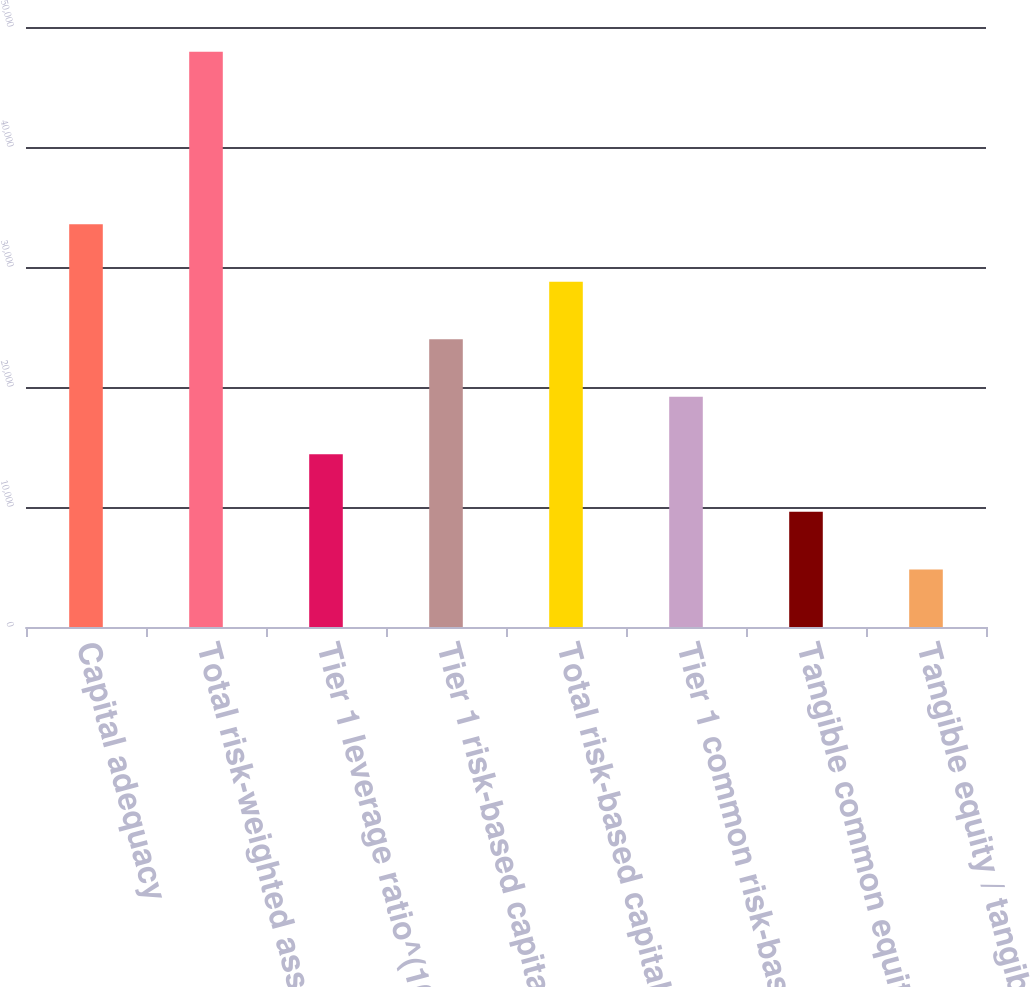<chart> <loc_0><loc_0><loc_500><loc_500><bar_chart><fcel>Capital adequacy<fcel>Total risk-weighted assets (in<fcel>Tier 1 leverage ratio^(10)<fcel>Tier 1 risk-based capital<fcel>Total risk-based capital<fcel>Tier 1 common risk-based<fcel>Tangible common equity /<fcel>Tangible equity / tangible<nl><fcel>33558.6<fcel>47937<fcel>14387.3<fcel>23973<fcel>28765.8<fcel>19180.2<fcel>9594.53<fcel>4801.72<nl></chart> 